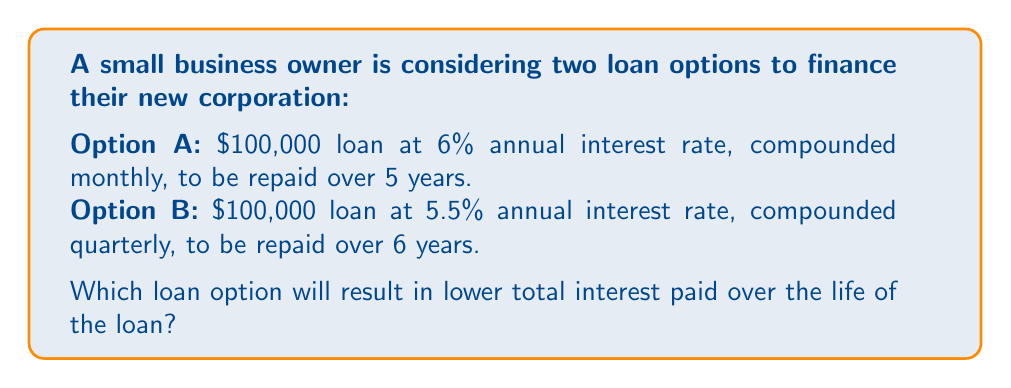What is the answer to this math problem? To determine which loan option results in lower total interest paid, we need to calculate the total amount repaid for each option and subtract the principal.

Step 1: Calculate the total amount repaid for Option A

Using the compound interest formula:
$A = P(1 + \frac{r}{n})^{nt}$

Where:
$A$ = Total amount repaid
$P$ = Principal ($100,000)
$r$ = Annual interest rate (6% = 0.06)
$n$ = Number of times interest is compounded per year (12 for monthly)
$t$ = Number of years (5)

$$A_A = 100000(1 + \frac{0.06}{12})^{12 * 5} = 133,888.72$$

Total interest paid for Option A = $133,888.72 - 100,000 = 33,888.72$

Step 2: Calculate the total amount repaid for Option B

Using the same formula with different values:
$P = 100,000$
$r = 5.5\% = 0.055$
$n = 4$ (quarterly compounding)
$t = 6$ years

$$A_B = 100000(1 + \frac{0.055}{4})^{4 * 6} = 138,571.80$$

Total interest paid for Option B = $138,571.80 - 100,000 = 38,571.80$

Step 3: Compare the total interest paid

Option A: $33,888.72
Option B: $38,571.80

Option A results in lower total interest paid over the life of the loan.
Answer: Option A 